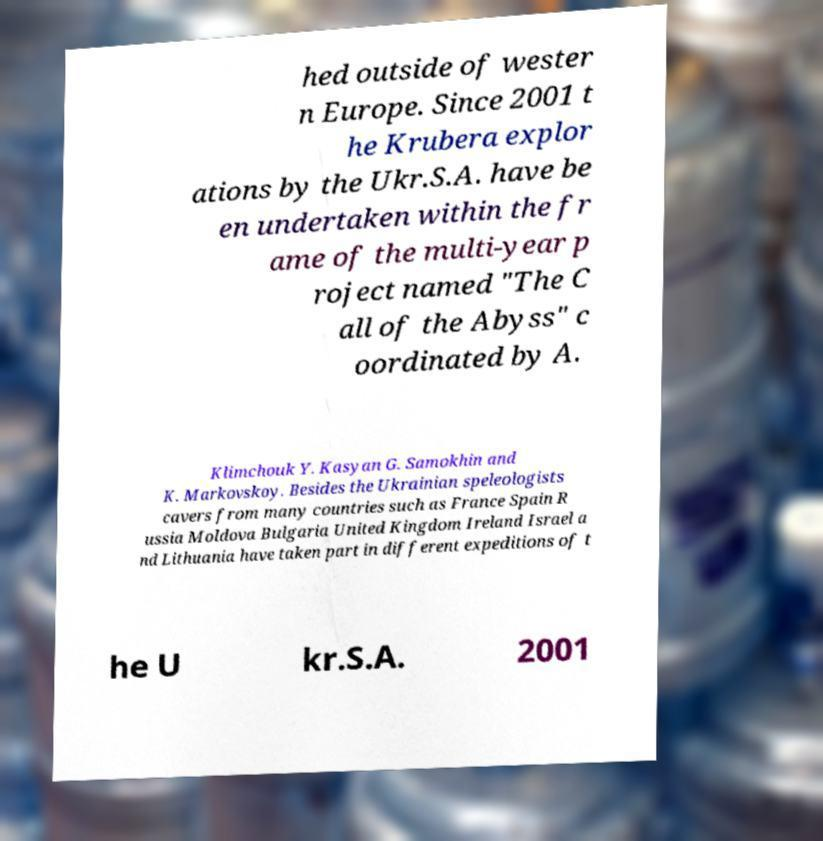For documentation purposes, I need the text within this image transcribed. Could you provide that? hed outside of wester n Europe. Since 2001 t he Krubera explor ations by the Ukr.S.A. have be en undertaken within the fr ame of the multi-year p roject named "The C all of the Abyss" c oordinated by A. Klimchouk Y. Kasyan G. Samokhin and K. Markovskoy. Besides the Ukrainian speleologists cavers from many countries such as France Spain R ussia Moldova Bulgaria United Kingdom Ireland Israel a nd Lithuania have taken part in different expeditions of t he U kr.S.A. 2001 